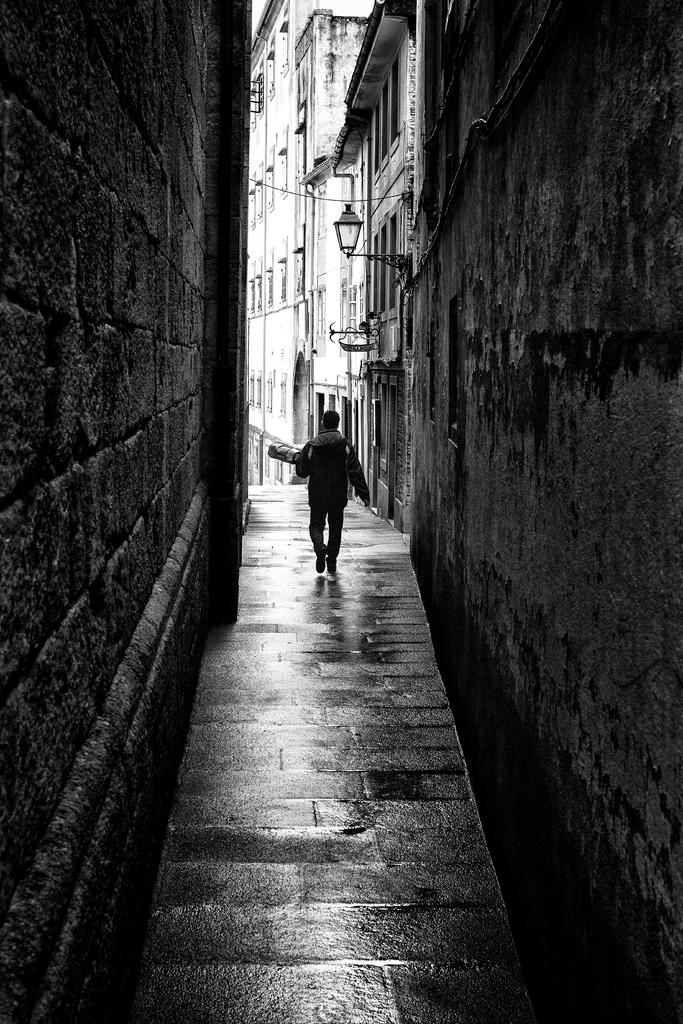What is located in the center of the image? There are buildings and a man in the center of the image. What can be seen on both sides of the image? There are walls on both the right and left sides of the image. What type of substance is being used to play with the balls in the image? There are no balls present in the image, so it is not possible to determine what substance might be used to play with them. 